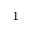<formula> <loc_0><loc_0><loc_500><loc_500>^ { 1 }</formula> 